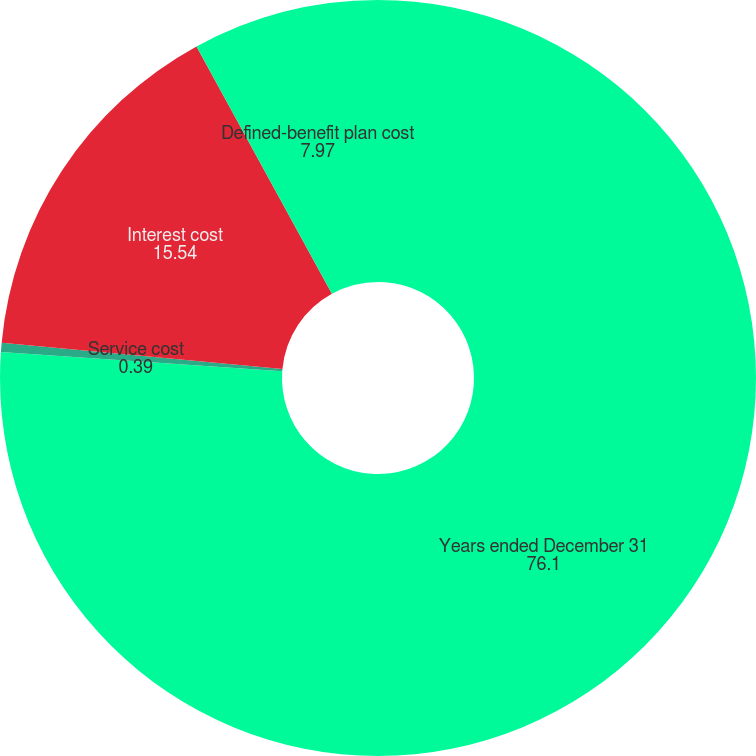<chart> <loc_0><loc_0><loc_500><loc_500><pie_chart><fcel>Years ended December 31<fcel>Service cost<fcel>Interest cost<fcel>Defined-benefit plan cost<nl><fcel>76.1%<fcel>0.39%<fcel>15.54%<fcel>7.97%<nl></chart> 